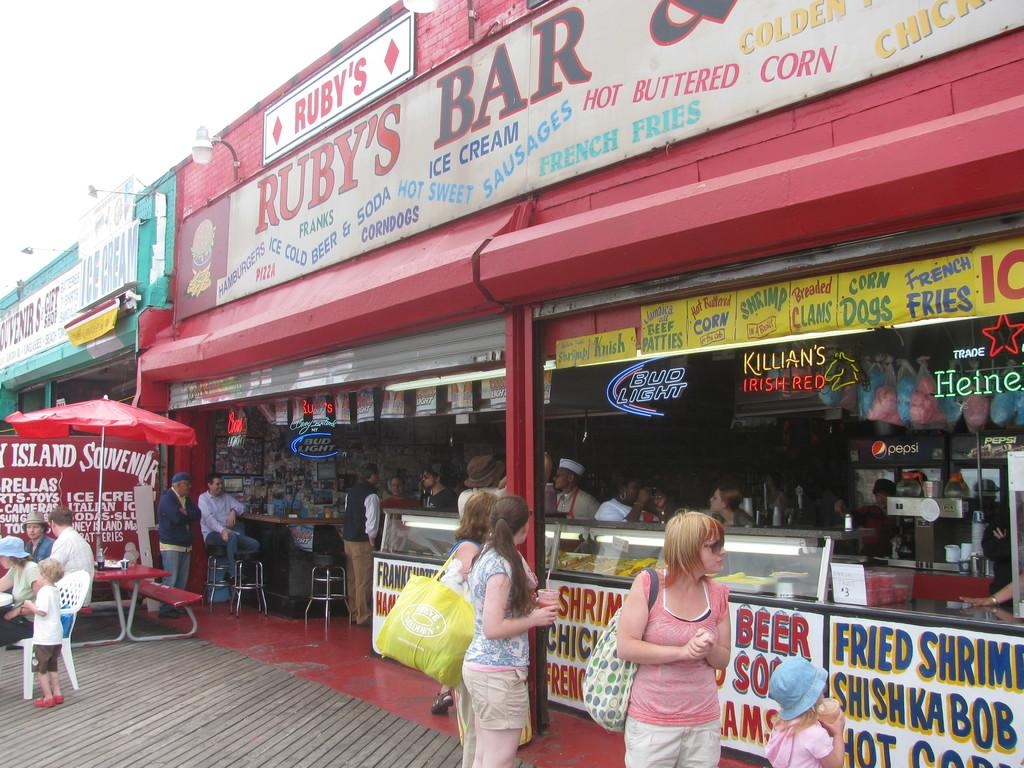<image>
Summarize the visual content of the image. A group of people are walking by a restaurant on a boardwalk called Ruby's Bar. 